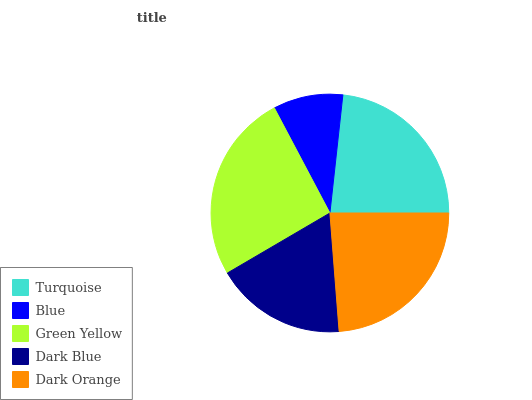Is Blue the minimum?
Answer yes or no. Yes. Is Green Yellow the maximum?
Answer yes or no. Yes. Is Green Yellow the minimum?
Answer yes or no. No. Is Blue the maximum?
Answer yes or no. No. Is Green Yellow greater than Blue?
Answer yes or no. Yes. Is Blue less than Green Yellow?
Answer yes or no. Yes. Is Blue greater than Green Yellow?
Answer yes or no. No. Is Green Yellow less than Blue?
Answer yes or no. No. Is Turquoise the high median?
Answer yes or no. Yes. Is Turquoise the low median?
Answer yes or no. Yes. Is Dark Blue the high median?
Answer yes or no. No. Is Green Yellow the low median?
Answer yes or no. No. 